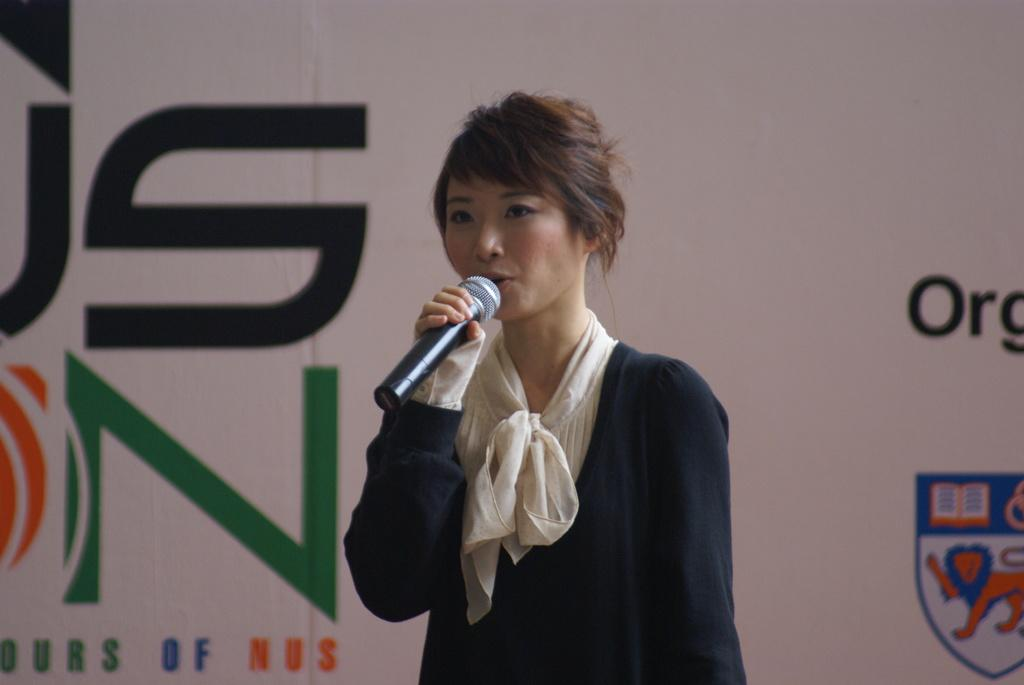Who is the main subject in the image? There is a woman in the image. What is the woman doing in the image? The woman is standing and talking into a microphone. How is the woman holding the microphone? The woman is holding the microphone. What can be seen in the background behind the woman? There is a banner visible behind the woman. What type of cheese is the owl eating in the image? There is no owl or cheese present in the image. How is the woman measuring the distance between the two objects in the image? The image does not show the woman measuring anything; she is talking into a microphone. 